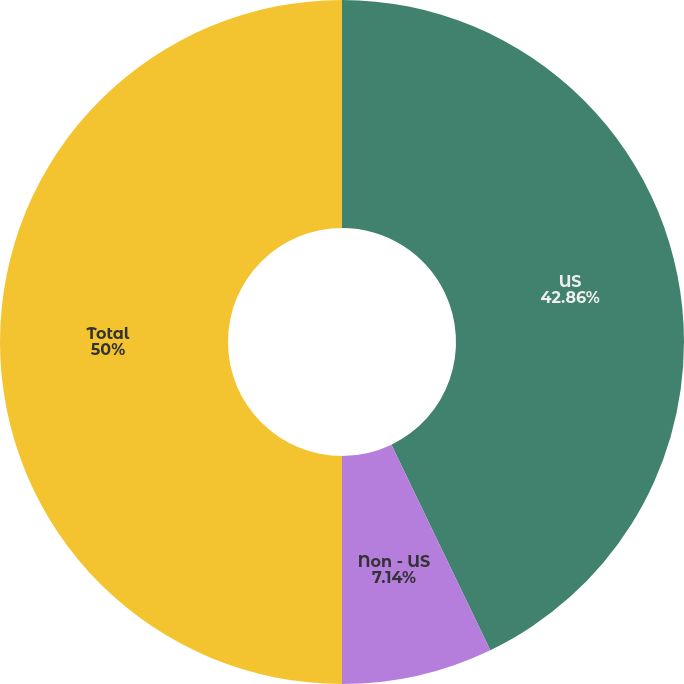<chart> <loc_0><loc_0><loc_500><loc_500><pie_chart><fcel>US<fcel>Non - US<fcel>Total<nl><fcel>42.86%<fcel>7.14%<fcel>50.0%<nl></chart> 